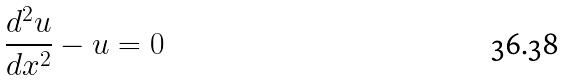Convert formula to latex. <formula><loc_0><loc_0><loc_500><loc_500>\frac { d ^ { 2 } u } { d x ^ { 2 } } - u = 0</formula> 